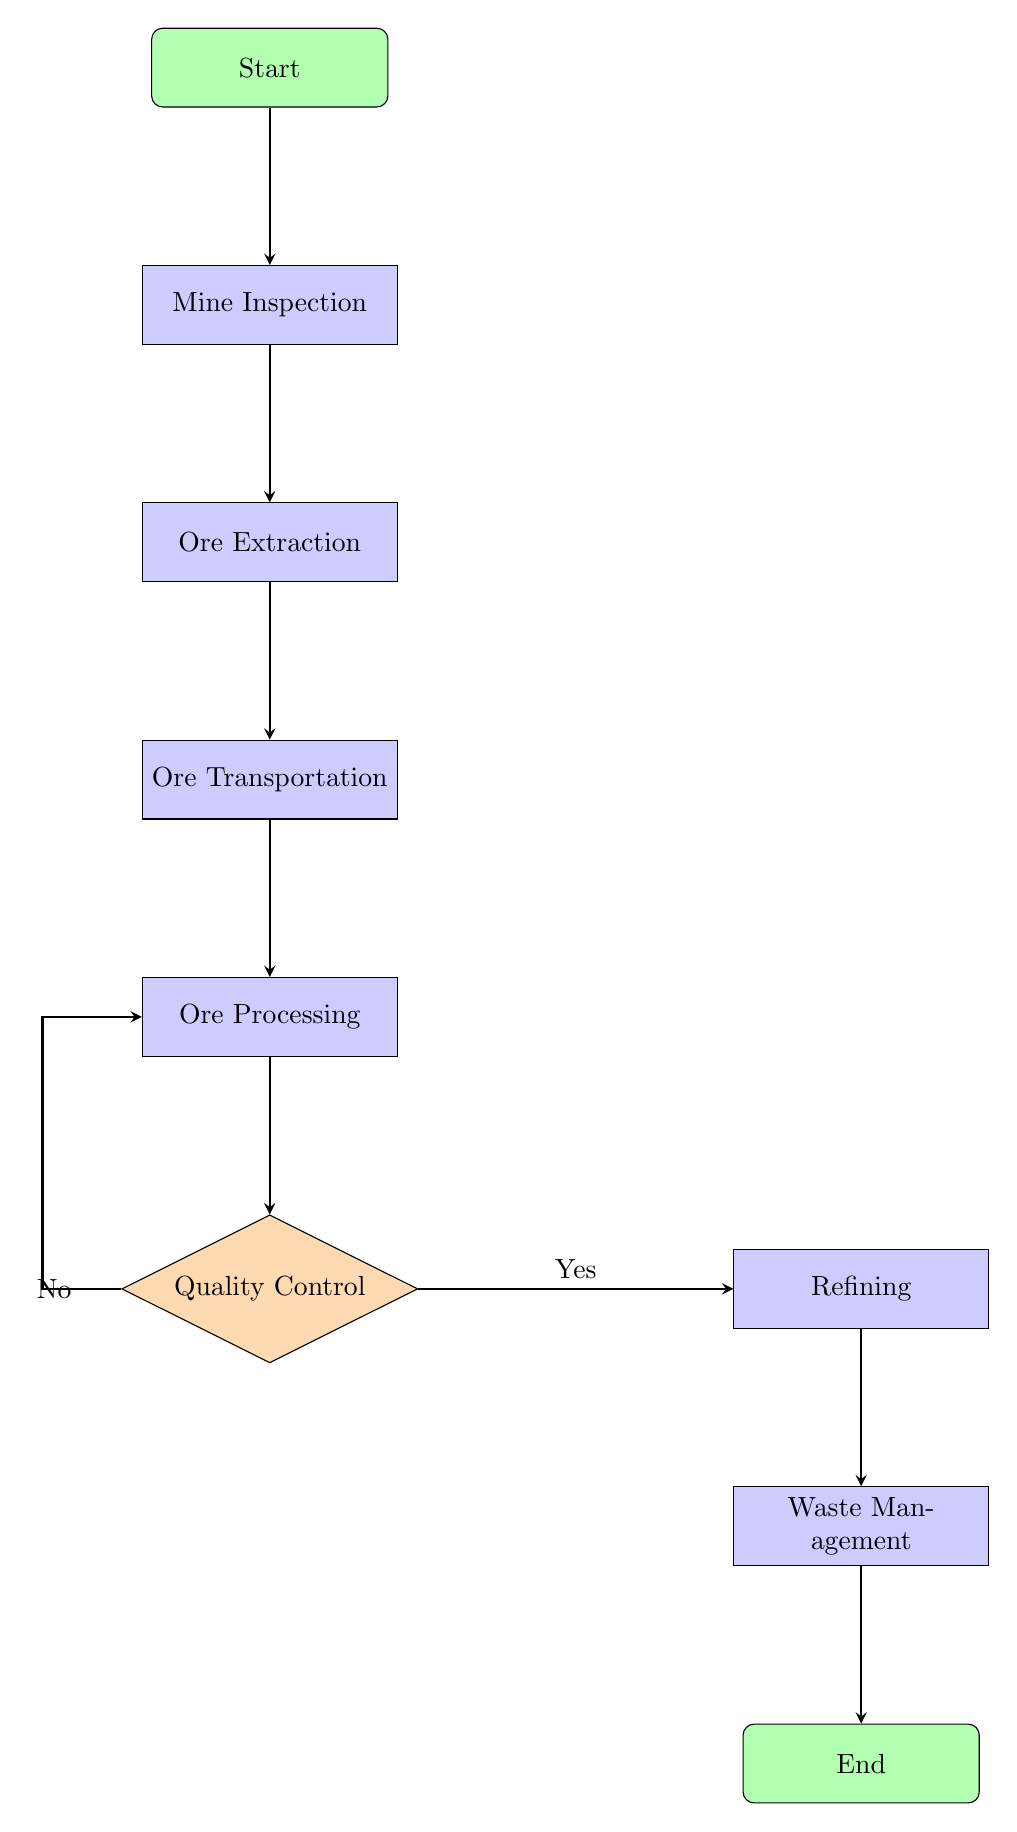What is the first step in the resource extraction process? The diagram indicates that the process starts with the "Start" node leading to "Mine Inspection" as the first step.
Answer: Mine Inspection How many major process nodes are in the workflow? The diagram consists of six major process nodes: "Mine Inspection," "Ore Extraction," "Ore Transportation," "Ore Processing," "Refining," and "Waste Management."
Answer: Six What action follows "Ore Processing" if the quality control is satisfactory? According to the flow chart, if quality control is satisfactory (Yes), the next action is "Refining."
Answer: Refining What happens if the ore fails quality control? The flow chart states that if the ore does not meet quality control (No), it loops back to "Ore Processing" for further processing.
Answer: Ore Processing What is the last step before the end of the process? The final step before reaching the end of the process is "Waste Management," which is the last process node leading to "End."
Answer: Waste Management What is the relationship between "Ore Transportation" and "Ore Processing"? The flow chart shows that "Ore Transportation" leads directly to "Ore Processing," indicating a sequential relationship between these two steps.
Answer: Sequential How many decision points are present in the diagram? The diagram contains one decision point at "Quality Control," from which the flow can diverge based on the outcome.
Answer: One What is the purpose of the "Mine Inspection" node? The purpose of "Mine Inspection" is to conduct a pre-extraction inspection ensuring that all equipment and safety measures are in place before proceeding.
Answer: Conduct a pre-extraction inspection Which node produces the final product of the workflow? The "Refining" node is responsible for transforming the processed ore into the final product, such as gold or copper.
Answer: Refining 